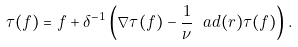<formula> <loc_0><loc_0><loc_500><loc_500>\tau ( f ) = f + \delta ^ { - 1 } \left ( \nabla \tau ( f ) - \frac { 1 } { \nu } \ a d ( r ) \tau ( f ) \right ) .</formula> 